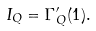Convert formula to latex. <formula><loc_0><loc_0><loc_500><loc_500>I _ { Q } = \Gamma _ { Q } ^ { \prime } ( 1 ) .</formula> 